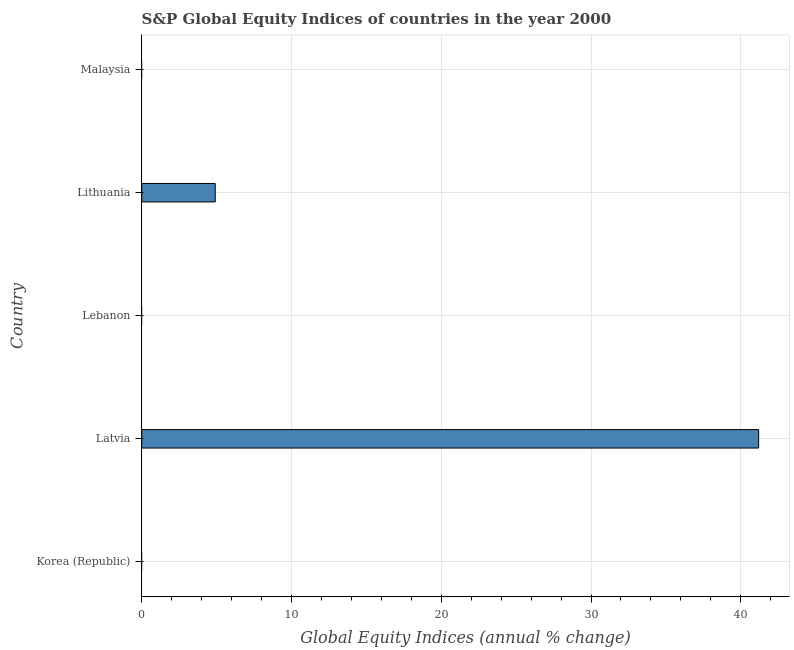What is the title of the graph?
Ensure brevity in your answer.  S&P Global Equity Indices of countries in the year 2000. What is the label or title of the X-axis?
Your answer should be compact. Global Equity Indices (annual % change). What is the label or title of the Y-axis?
Provide a short and direct response. Country. Across all countries, what is the maximum s&p global equity indices?
Your response must be concise. 41.19. In which country was the s&p global equity indices maximum?
Ensure brevity in your answer.  Latvia. What is the sum of the s&p global equity indices?
Provide a short and direct response. 46.1. What is the difference between the s&p global equity indices in Latvia and Lithuania?
Provide a short and direct response. 36.28. What is the average s&p global equity indices per country?
Ensure brevity in your answer.  9.22. What is the median s&p global equity indices?
Your response must be concise. 0. In how many countries, is the s&p global equity indices greater than 34 %?
Offer a very short reply. 1. Is the difference between the s&p global equity indices in Latvia and Lithuania greater than the difference between any two countries?
Provide a short and direct response. No. What is the difference between the highest and the lowest s&p global equity indices?
Provide a succinct answer. 41.19. How many bars are there?
Your answer should be very brief. 2. What is the Global Equity Indices (annual % change) in Korea (Republic)?
Provide a succinct answer. 0. What is the Global Equity Indices (annual % change) of Latvia?
Make the answer very short. 41.19. What is the Global Equity Indices (annual % change) in Lithuania?
Give a very brief answer. 4.91. What is the difference between the Global Equity Indices (annual % change) in Latvia and Lithuania?
Offer a very short reply. 36.28. What is the ratio of the Global Equity Indices (annual % change) in Latvia to that in Lithuania?
Offer a terse response. 8.39. 